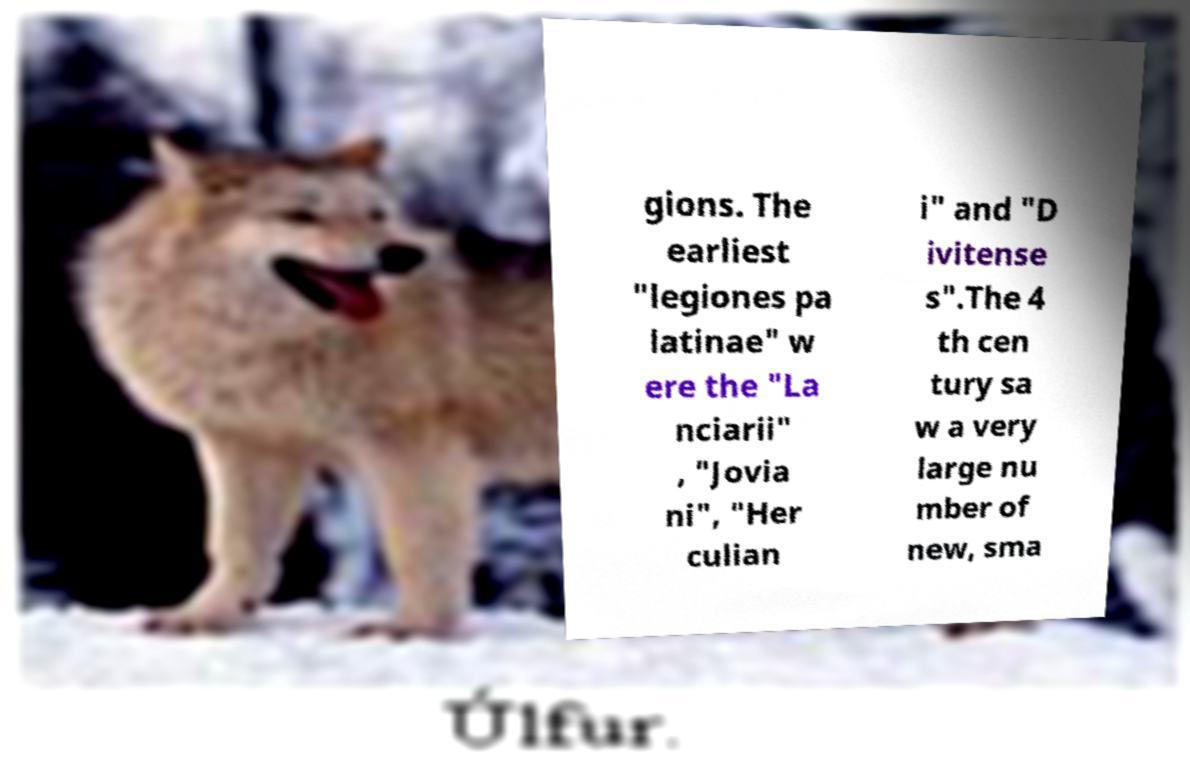I need the written content from this picture converted into text. Can you do that? gions. The earliest "legiones pa latinae" w ere the "La nciarii" , "Jovia ni", "Her culian i" and "D ivitense s".The 4 th cen tury sa w a very large nu mber of new, sma 